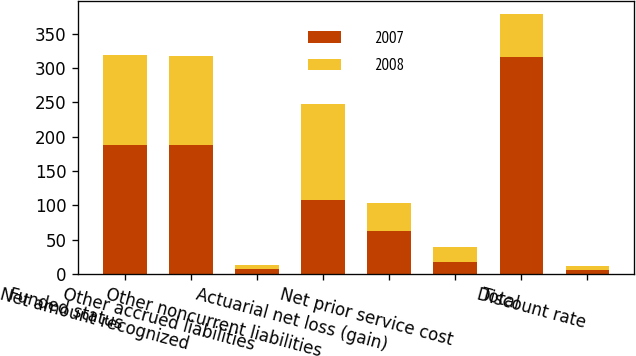Convert chart to OTSL. <chart><loc_0><loc_0><loc_500><loc_500><stacked_bar_chart><ecel><fcel>Funded status<fcel>Net amount recognized<fcel>Other accrued liabilities<fcel>Other noncurrent liabilities<fcel>Actuarial net loss (gain)<fcel>Net prior service cost<fcel>Total<fcel>Discount rate<nl><fcel>2007<fcel>188.3<fcel>188.3<fcel>6.7<fcel>107.5<fcel>62.7<fcel>17.7<fcel>316.5<fcel>6.6<nl><fcel>2008<fcel>130.9<fcel>128.9<fcel>6.3<fcel>140.3<fcel>41.2<fcel>21.5<fcel>62.7<fcel>5.75<nl></chart> 